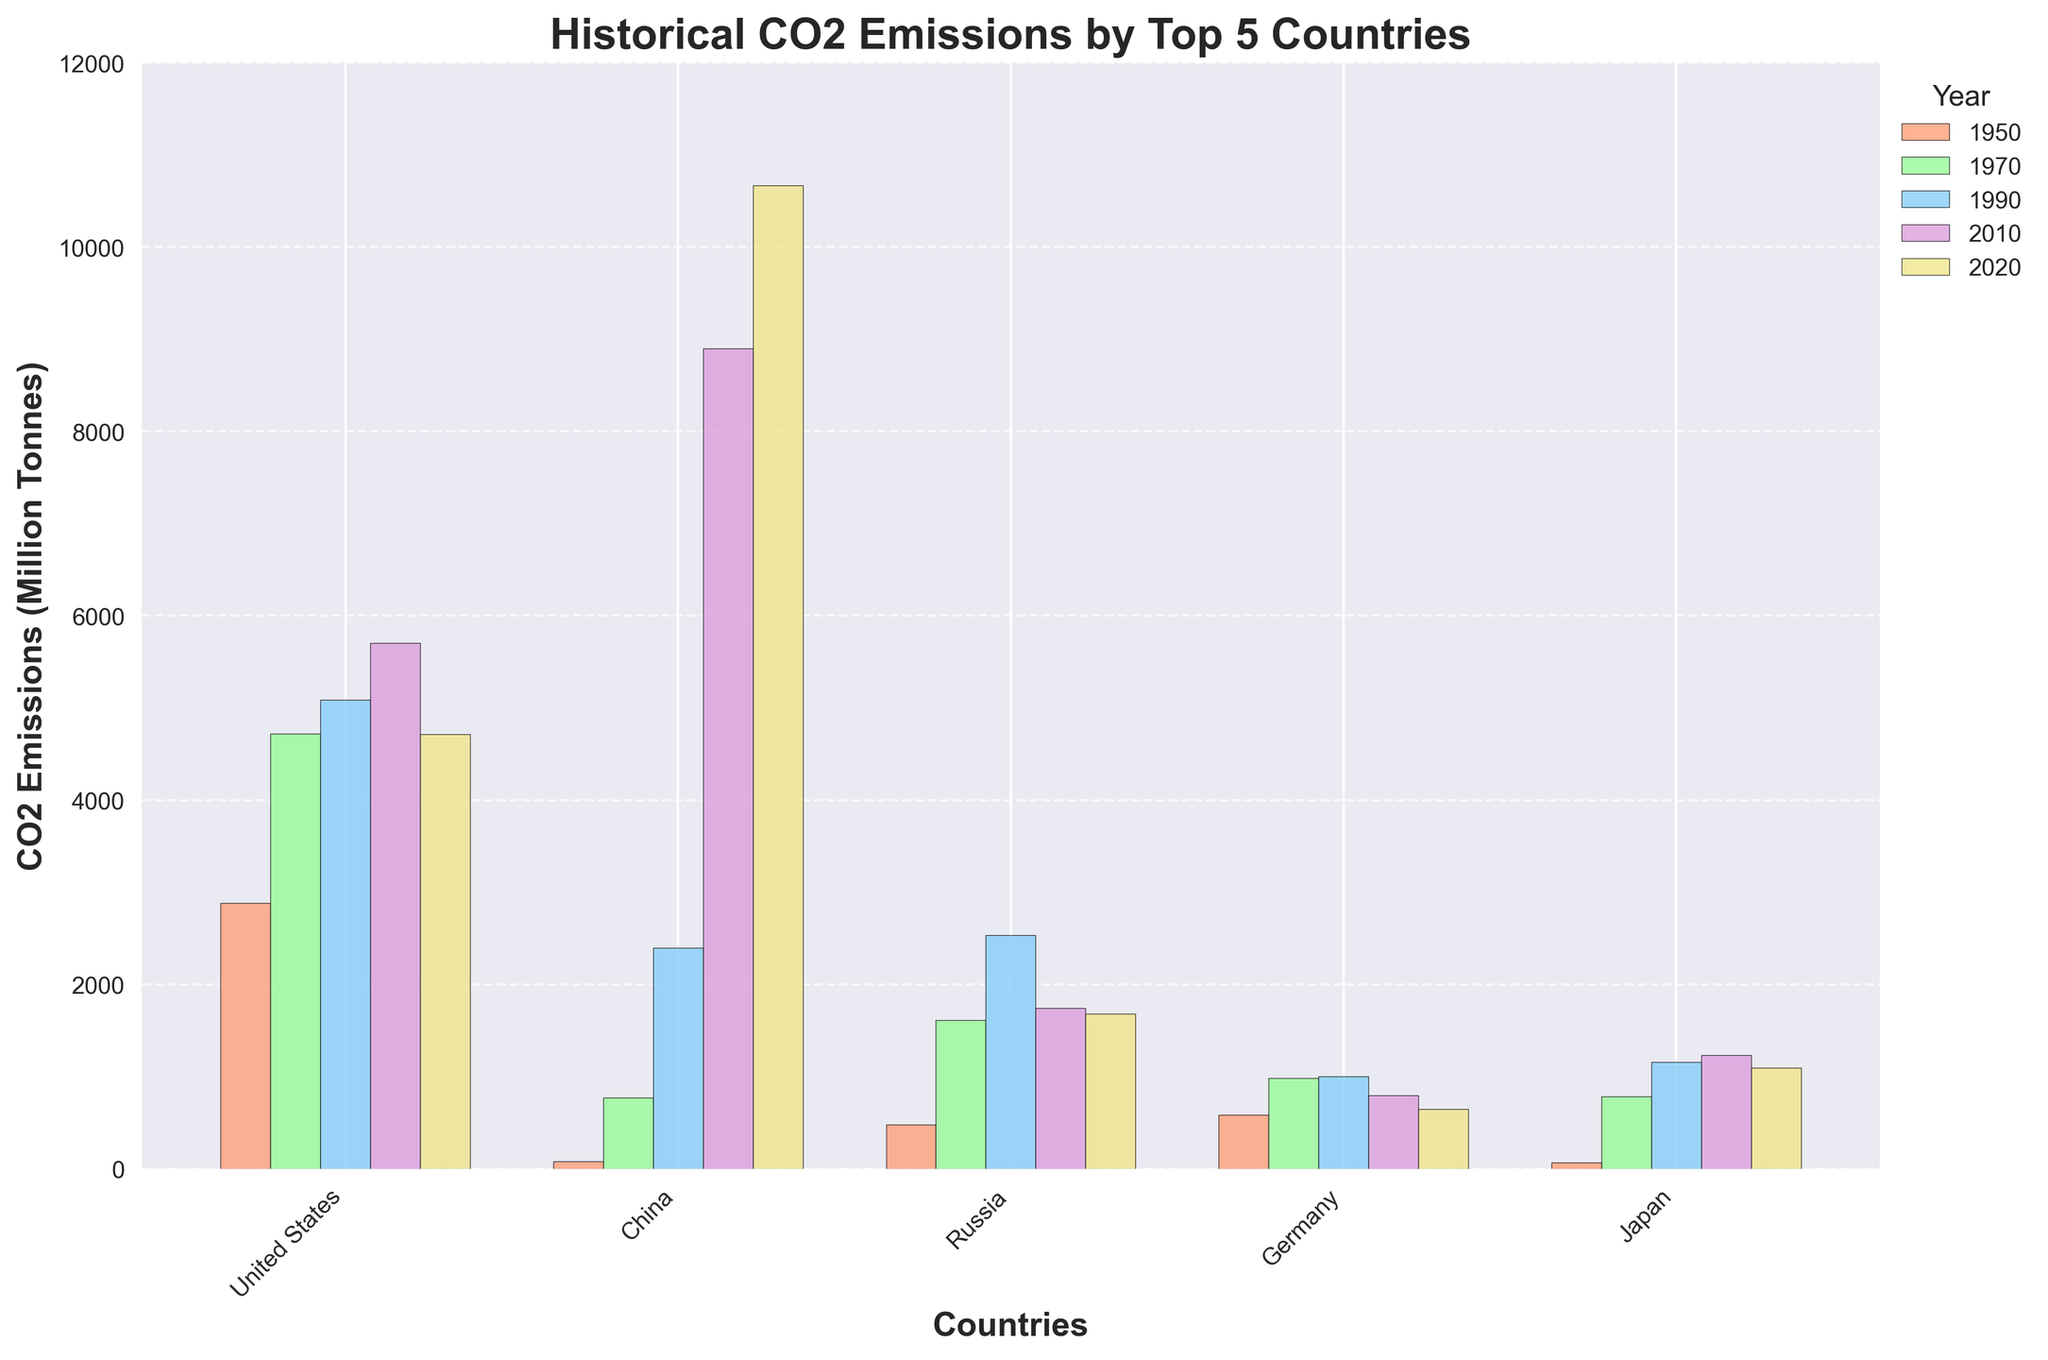What was the total CO2 emissions for the United States and China in 2020? Add the emissions for the United States (4712) and China (10667) for 2020. 4712 + 10667 = 15379
Answer: 15379 Which country had the highest CO2 emissions in 1990? Check the height of the bars for 1990 and identify the one that is the tallest. China has the tallest bar with emissions of 2398.
Answer: China How did Japan's CO2 emissions in 1970 compare to those in 2010? Note the height of the bars for Japan in 1970 (781) and 2010 (1231). Subtract the 1970 value from the 2010 value: 1231 - 781 = 450. So, emissions increased by 450.
Answer: Increased by 450 In which year did Germany have the lowest CO2 emissions according to the chart? Observe the bars for Germany over all the years and identify the shortest one. Germany has the shortest bar in 2020 with emissions of 644.
Answer: 2020 Between 1950 and 2020, which country showed the largest increase in CO2 emissions? Compare the emissions in 1950 and 2020 for all countries and find the largest difference. China increased from 79 in 1950 to 10667 in 2020, an increase of 10588, which is the largest among all countries.
Answer: China How much did Russia’s CO2 emissions change between 1990 and 2020? Look at Russia's emissions for 1990 (2532) and 2020 (1678). Subtract the 2020 value from the 1990 value: 2532 - 1678 = 854. So the emissions decreased by 854.
Answer: Decreased by 854 Which country had the least CO2 emissions in 1950? Check the heights of the bars for 1950 and identify the shortest one. Japan has the smallest bar with emissions of 68.
Answer: Japan Did any country have lower CO2 emissions in 2020 compared to 2010? If so, which one(s)? Compare the bar heights for 2010 and 2020 for each country. The United States and Russia both had lower emissions in 2020 compared to 2010.
Answer: United States, Russia How do the CO2 emissions of Germany in 1950 compare to those of Japan in 1950? Note the height of the bars for Germany (583) and Japan (68) in 1950. Germany's emissions are 515 higher than Japan's. 583 - 68 = 515.
Answer: Germany's emissions were 515 higher What is the combined CO2 emissions for all five countries in 2010? Sum the emissions of the United States (5701), China (8897), Russia (1740), Germany (798), and Japan (1231) for 2010: 5701 + 8897 + 1740 + 798 + 1231 = 18367.
Answer: 18367 